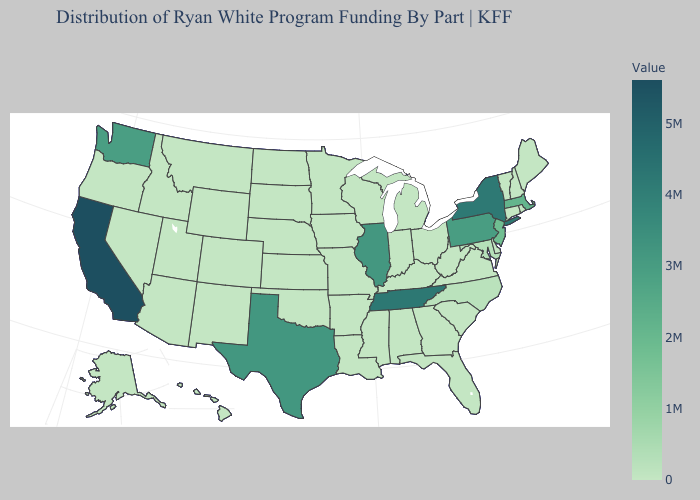Among the states that border Nebraska , which have the highest value?
Be succinct. Colorado, Iowa, Kansas, Missouri, South Dakota, Wyoming. Which states have the highest value in the USA?
Answer briefly. California. Is the legend a continuous bar?
Give a very brief answer. Yes. Does Iowa have the lowest value in the MidWest?
Write a very short answer. Yes. 